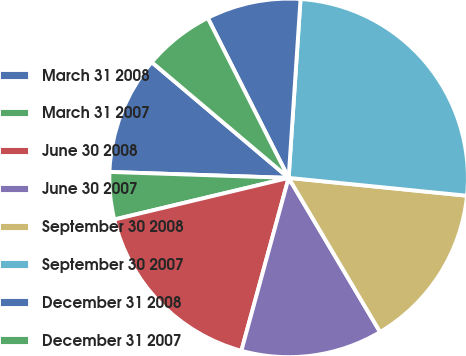Convert chart to OTSL. <chart><loc_0><loc_0><loc_500><loc_500><pie_chart><fcel>March 31 2008<fcel>March 31 2007<fcel>June 30 2008<fcel>June 30 2007<fcel>September 30 2008<fcel>September 30 2007<fcel>December 31 2008<fcel>December 31 2007<nl><fcel>10.64%<fcel>4.26%<fcel>17.02%<fcel>12.77%<fcel>14.89%<fcel>25.53%<fcel>8.51%<fcel>6.38%<nl></chart> 